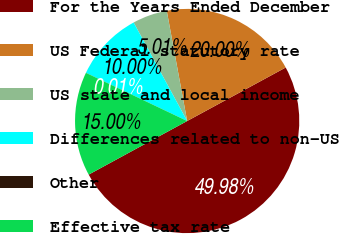Convert chart. <chart><loc_0><loc_0><loc_500><loc_500><pie_chart><fcel>For the Years Ended December<fcel>US Federal statutory rate<fcel>US state and local income<fcel>Differences related to non-US<fcel>Other<fcel>Effective tax rate<nl><fcel>49.99%<fcel>20.0%<fcel>5.01%<fcel>10.0%<fcel>0.01%<fcel>15.0%<nl></chart> 